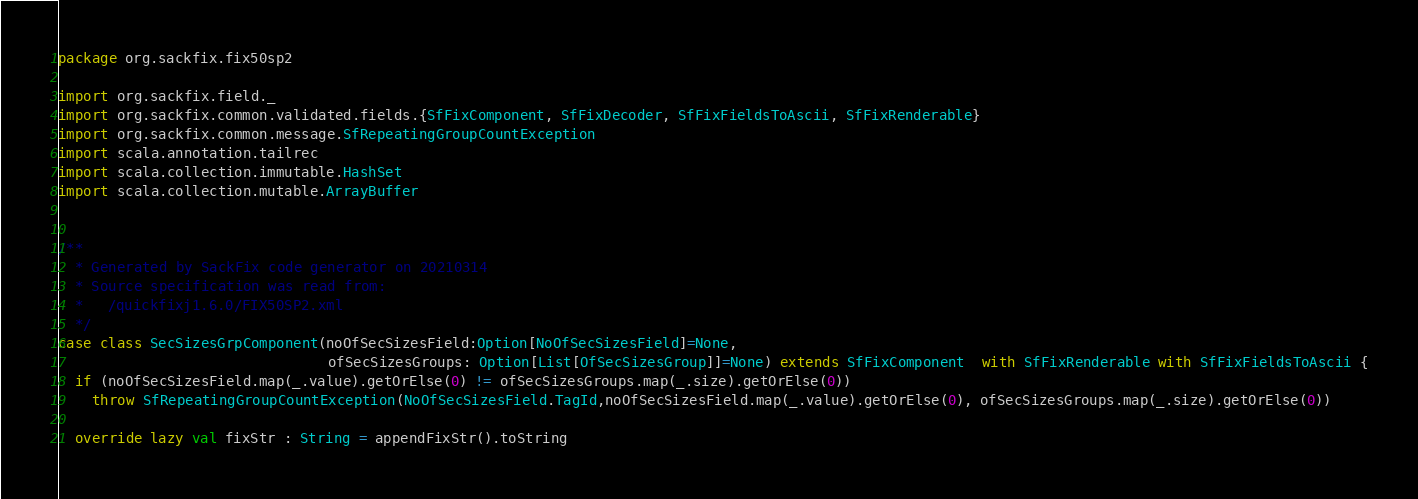Convert code to text. <code><loc_0><loc_0><loc_500><loc_500><_Scala_>package org.sackfix.fix50sp2

import org.sackfix.field._
import org.sackfix.common.validated.fields.{SfFixComponent, SfFixDecoder, SfFixFieldsToAscii, SfFixRenderable}
import org.sackfix.common.message.SfRepeatingGroupCountException
import scala.annotation.tailrec
import scala.collection.immutable.HashSet
import scala.collection.mutable.ArrayBuffer


/**
  * Generated by SackFix code generator on 20210314
  * Source specification was read from:
  *   /quickfixj1.6.0/FIX50SP2.xml
  */
case class SecSizesGrpComponent(noOfSecSizesField:Option[NoOfSecSizesField]=None,
                                ofSecSizesGroups: Option[List[OfSecSizesGroup]]=None) extends SfFixComponent  with SfFixRenderable with SfFixFieldsToAscii {
  if (noOfSecSizesField.map(_.value).getOrElse(0) != ofSecSizesGroups.map(_.size).getOrElse(0))
    throw SfRepeatingGroupCountException(NoOfSecSizesField.TagId,noOfSecSizesField.map(_.value).getOrElse(0), ofSecSizesGroups.map(_.size).getOrElse(0))

  override lazy val fixStr : String = appendFixStr().toString</code> 